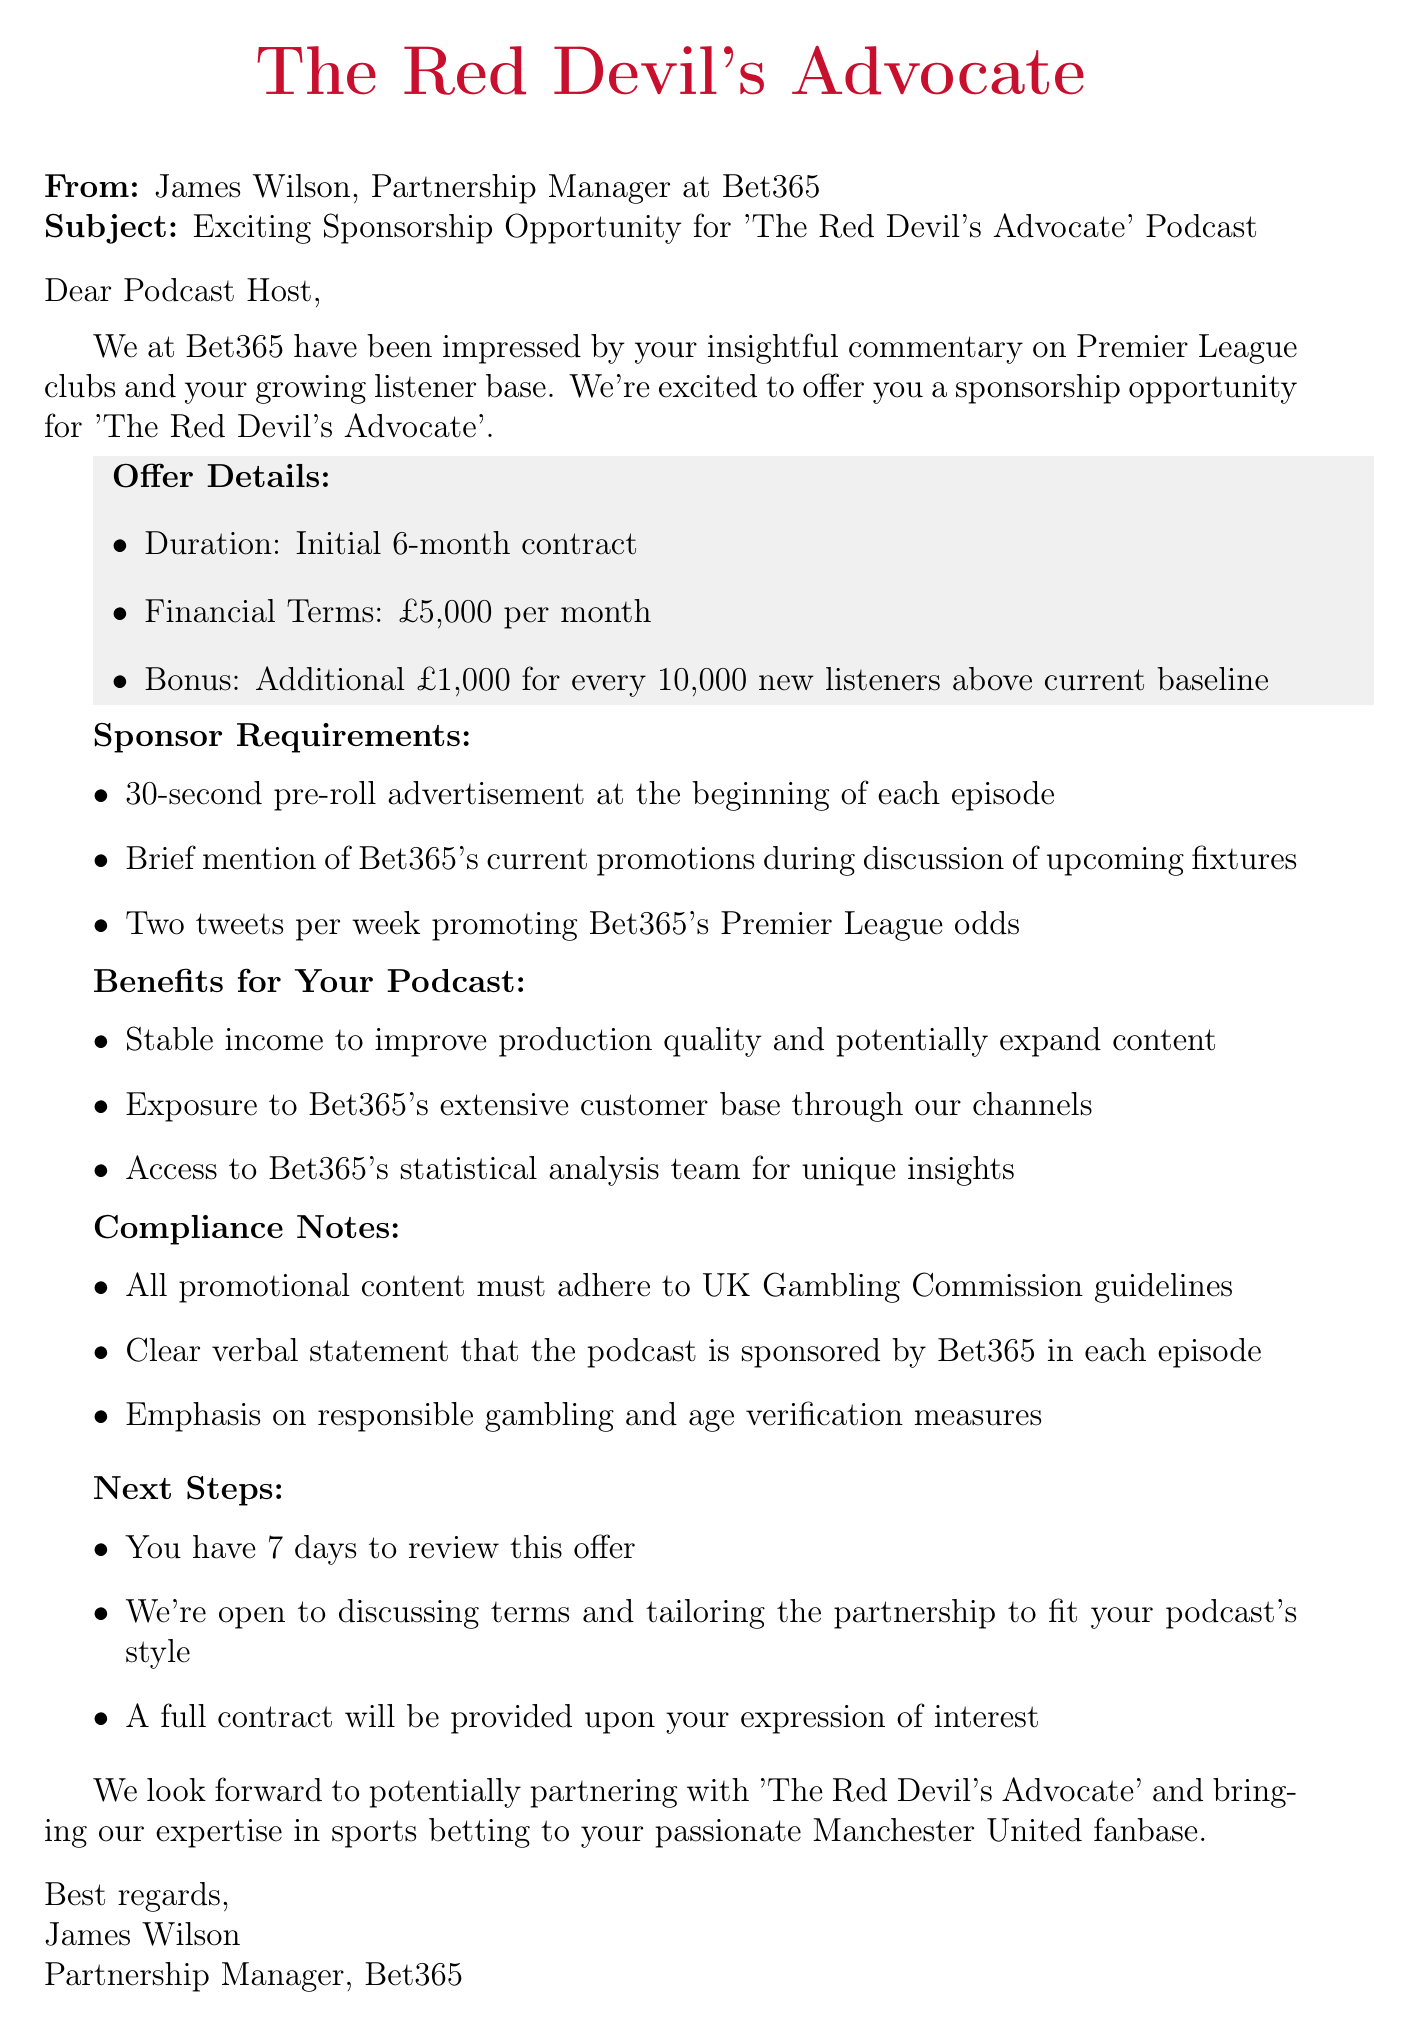what is the initial contract duration? The initial contract duration is explicitly stated in the offer details section of the email.
Answer: Initial 6-month contract what is the monthly sponsorship amount? The financial terms clearly indicate the sponsorship amount on a monthly basis.
Answer: £5,000 per month how much is the bonus for new listeners? The bonus structure provides details on additional earnings based on new listeners' count.
Answer: £1,000 for every 10,000 new listeners above current baseline what type of advertisement is required? The sponsor requirements section specifies the type of advertisement that should be included in each episode.
Answer: 30-second pre-roll advertisement how many tweets per week are needed? The requirements section mentions the frequency of tweets that should be posted to promote Bet365.
Answer: Two tweets per week what are the compliance guidelines regarding gambling? The compliance notes highlight specific requirements that must be followed for promotional content.
Answer: UK Gambling Commission guidelines what is the next step after reviewing the offer? The next steps clearly outline the procedures following the review period of the offer.
Answer: Open to discussing terms what is the company name offering the sponsorship? The introduction section identifies the company making the sponsorship offer.
Answer: Bet365 what aspect of the podcast will benefit from this sponsorship? The benefits for the podcast section outlines the advantages the podcast will gain from this sponsorship.
Answer: Stable income to improve production quality 